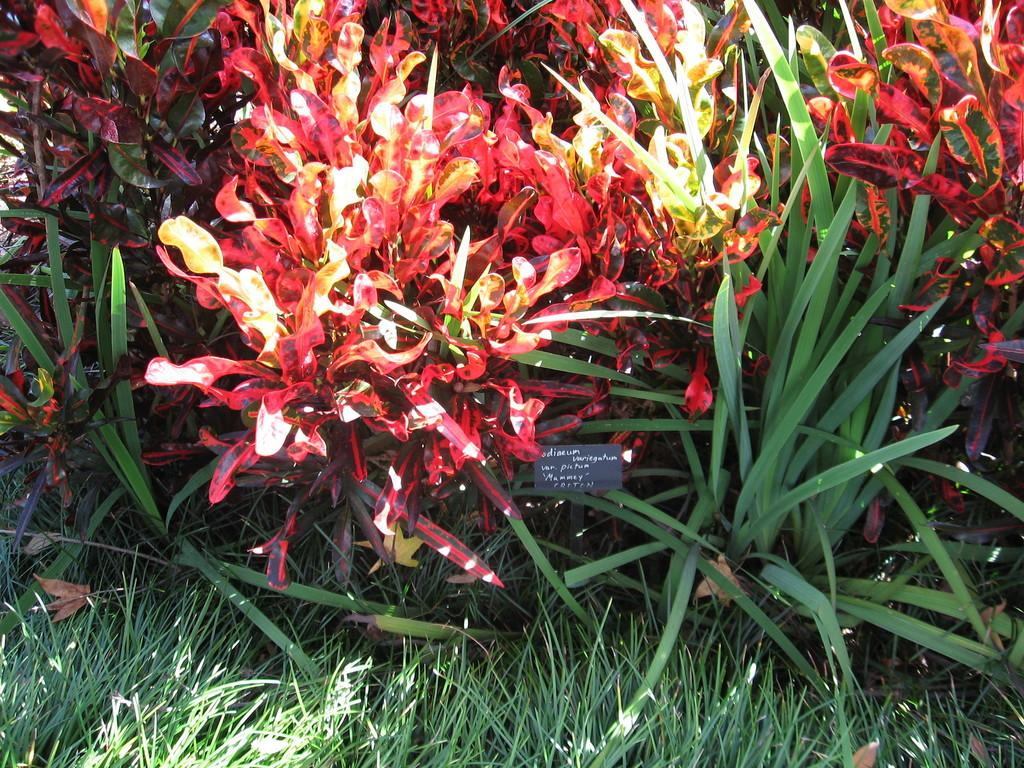What type of vegetation can be seen in the image? There are flower plants and grass in the image. Can you describe the natural environment depicted in the image? The image features flower plants and grass, which are both common elements of natural landscapes. How many trays can be seen in the image? There are no trays present in the image. What type of sponge is used to water the plants in the image? There is no sponge visible in the image, and it is not clear how the plants are being watered. 